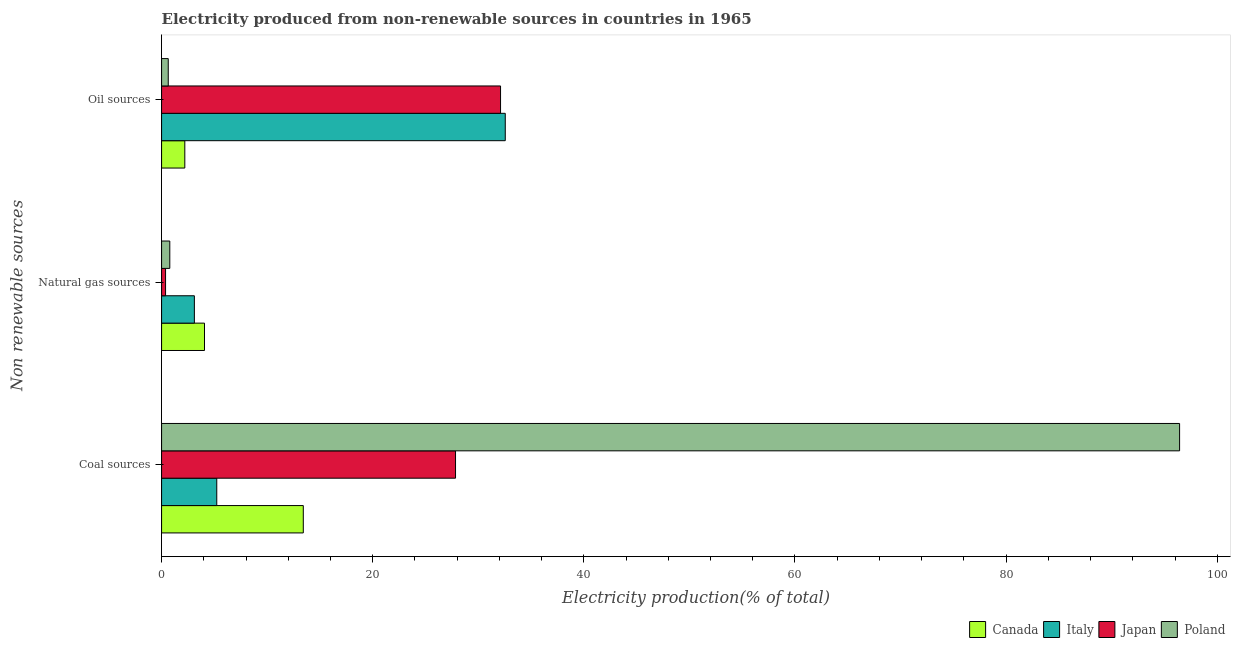How many different coloured bars are there?
Offer a very short reply. 4. How many groups of bars are there?
Keep it short and to the point. 3. Are the number of bars per tick equal to the number of legend labels?
Provide a succinct answer. Yes. What is the label of the 3rd group of bars from the top?
Give a very brief answer. Coal sources. What is the percentage of electricity produced by coal in Japan?
Your response must be concise. 27.85. Across all countries, what is the maximum percentage of electricity produced by coal?
Offer a very short reply. 96.43. Across all countries, what is the minimum percentage of electricity produced by oil sources?
Your answer should be very brief. 0.63. In which country was the percentage of electricity produced by natural gas minimum?
Make the answer very short. Japan. What is the total percentage of electricity produced by natural gas in the graph?
Keep it short and to the point. 8.33. What is the difference between the percentage of electricity produced by natural gas in Poland and that in Canada?
Offer a terse response. -3.29. What is the difference between the percentage of electricity produced by coal in Italy and the percentage of electricity produced by oil sources in Japan?
Provide a short and direct response. -26.88. What is the average percentage of electricity produced by oil sources per country?
Keep it short and to the point. 16.87. What is the difference between the percentage of electricity produced by natural gas and percentage of electricity produced by coal in Poland?
Make the answer very short. -95.65. What is the ratio of the percentage of electricity produced by coal in Italy to that in Poland?
Provide a succinct answer. 0.05. Is the percentage of electricity produced by natural gas in Poland less than that in Japan?
Keep it short and to the point. No. What is the difference between the highest and the second highest percentage of electricity produced by natural gas?
Offer a very short reply. 0.96. What is the difference between the highest and the lowest percentage of electricity produced by oil sources?
Ensure brevity in your answer.  31.92. Are all the bars in the graph horizontal?
Provide a short and direct response. Yes. What is the difference between two consecutive major ticks on the X-axis?
Your answer should be compact. 20. How many legend labels are there?
Offer a very short reply. 4. What is the title of the graph?
Provide a short and direct response. Electricity produced from non-renewable sources in countries in 1965. What is the label or title of the Y-axis?
Your answer should be very brief. Non renewable sources. What is the Electricity production(% of total) in Canada in Coal sources?
Give a very brief answer. 13.42. What is the Electricity production(% of total) of Italy in Coal sources?
Make the answer very short. 5.23. What is the Electricity production(% of total) of Japan in Coal sources?
Your answer should be compact. 27.85. What is the Electricity production(% of total) of Poland in Coal sources?
Provide a succinct answer. 96.43. What is the Electricity production(% of total) of Canada in Natural gas sources?
Your answer should be very brief. 4.07. What is the Electricity production(% of total) in Italy in Natural gas sources?
Offer a terse response. 3.11. What is the Electricity production(% of total) of Japan in Natural gas sources?
Offer a very short reply. 0.38. What is the Electricity production(% of total) of Poland in Natural gas sources?
Make the answer very short. 0.78. What is the Electricity production(% of total) in Canada in Oil sources?
Ensure brevity in your answer.  2.2. What is the Electricity production(% of total) of Italy in Oil sources?
Make the answer very short. 32.56. What is the Electricity production(% of total) of Japan in Oil sources?
Your response must be concise. 32.11. What is the Electricity production(% of total) of Poland in Oil sources?
Your response must be concise. 0.63. Across all Non renewable sources, what is the maximum Electricity production(% of total) of Canada?
Make the answer very short. 13.42. Across all Non renewable sources, what is the maximum Electricity production(% of total) in Italy?
Offer a very short reply. 32.56. Across all Non renewable sources, what is the maximum Electricity production(% of total) of Japan?
Your answer should be very brief. 32.11. Across all Non renewable sources, what is the maximum Electricity production(% of total) of Poland?
Ensure brevity in your answer.  96.43. Across all Non renewable sources, what is the minimum Electricity production(% of total) in Canada?
Offer a very short reply. 2.2. Across all Non renewable sources, what is the minimum Electricity production(% of total) of Italy?
Ensure brevity in your answer.  3.11. Across all Non renewable sources, what is the minimum Electricity production(% of total) in Japan?
Make the answer very short. 0.38. Across all Non renewable sources, what is the minimum Electricity production(% of total) of Poland?
Your answer should be very brief. 0.63. What is the total Electricity production(% of total) in Canada in the graph?
Offer a terse response. 19.69. What is the total Electricity production(% of total) in Italy in the graph?
Provide a succinct answer. 40.89. What is the total Electricity production(% of total) of Japan in the graph?
Provide a short and direct response. 60.33. What is the total Electricity production(% of total) in Poland in the graph?
Provide a short and direct response. 97.84. What is the difference between the Electricity production(% of total) of Canada in Coal sources and that in Natural gas sources?
Make the answer very short. 9.36. What is the difference between the Electricity production(% of total) in Italy in Coal sources and that in Natural gas sources?
Give a very brief answer. 2.12. What is the difference between the Electricity production(% of total) in Japan in Coal sources and that in Natural gas sources?
Offer a terse response. 27.47. What is the difference between the Electricity production(% of total) of Poland in Coal sources and that in Natural gas sources?
Your response must be concise. 95.65. What is the difference between the Electricity production(% of total) in Canada in Coal sources and that in Oil sources?
Offer a very short reply. 11.22. What is the difference between the Electricity production(% of total) of Italy in Coal sources and that in Oil sources?
Make the answer very short. -27.33. What is the difference between the Electricity production(% of total) of Japan in Coal sources and that in Oil sources?
Give a very brief answer. -4.26. What is the difference between the Electricity production(% of total) of Poland in Coal sources and that in Oil sources?
Keep it short and to the point. 95.8. What is the difference between the Electricity production(% of total) of Canada in Natural gas sources and that in Oil sources?
Offer a terse response. 1.86. What is the difference between the Electricity production(% of total) of Italy in Natural gas sources and that in Oil sources?
Ensure brevity in your answer.  -29.45. What is the difference between the Electricity production(% of total) of Japan in Natural gas sources and that in Oil sources?
Offer a terse response. -31.73. What is the difference between the Electricity production(% of total) of Poland in Natural gas sources and that in Oil sources?
Make the answer very short. 0.15. What is the difference between the Electricity production(% of total) of Canada in Coal sources and the Electricity production(% of total) of Italy in Natural gas sources?
Provide a succinct answer. 10.32. What is the difference between the Electricity production(% of total) of Canada in Coal sources and the Electricity production(% of total) of Japan in Natural gas sources?
Offer a very short reply. 13.05. What is the difference between the Electricity production(% of total) in Canada in Coal sources and the Electricity production(% of total) in Poland in Natural gas sources?
Your answer should be very brief. 12.65. What is the difference between the Electricity production(% of total) of Italy in Coal sources and the Electricity production(% of total) of Japan in Natural gas sources?
Provide a succinct answer. 4.85. What is the difference between the Electricity production(% of total) in Italy in Coal sources and the Electricity production(% of total) in Poland in Natural gas sources?
Your answer should be very brief. 4.45. What is the difference between the Electricity production(% of total) in Japan in Coal sources and the Electricity production(% of total) in Poland in Natural gas sources?
Make the answer very short. 27.07. What is the difference between the Electricity production(% of total) of Canada in Coal sources and the Electricity production(% of total) of Italy in Oil sources?
Your answer should be compact. -19.13. What is the difference between the Electricity production(% of total) of Canada in Coal sources and the Electricity production(% of total) of Japan in Oil sources?
Your response must be concise. -18.68. What is the difference between the Electricity production(% of total) in Canada in Coal sources and the Electricity production(% of total) in Poland in Oil sources?
Provide a short and direct response. 12.79. What is the difference between the Electricity production(% of total) of Italy in Coal sources and the Electricity production(% of total) of Japan in Oil sources?
Provide a succinct answer. -26.88. What is the difference between the Electricity production(% of total) in Italy in Coal sources and the Electricity production(% of total) in Poland in Oil sources?
Provide a succinct answer. 4.6. What is the difference between the Electricity production(% of total) of Japan in Coal sources and the Electricity production(% of total) of Poland in Oil sources?
Your answer should be compact. 27.21. What is the difference between the Electricity production(% of total) in Canada in Natural gas sources and the Electricity production(% of total) in Italy in Oil sources?
Ensure brevity in your answer.  -28.49. What is the difference between the Electricity production(% of total) in Canada in Natural gas sources and the Electricity production(% of total) in Japan in Oil sources?
Ensure brevity in your answer.  -28.04. What is the difference between the Electricity production(% of total) in Canada in Natural gas sources and the Electricity production(% of total) in Poland in Oil sources?
Offer a very short reply. 3.43. What is the difference between the Electricity production(% of total) in Italy in Natural gas sources and the Electricity production(% of total) in Japan in Oil sources?
Provide a succinct answer. -29. What is the difference between the Electricity production(% of total) of Italy in Natural gas sources and the Electricity production(% of total) of Poland in Oil sources?
Your response must be concise. 2.47. What is the difference between the Electricity production(% of total) of Japan in Natural gas sources and the Electricity production(% of total) of Poland in Oil sources?
Give a very brief answer. -0.26. What is the average Electricity production(% of total) in Canada per Non renewable sources?
Your response must be concise. 6.56. What is the average Electricity production(% of total) in Italy per Non renewable sources?
Ensure brevity in your answer.  13.63. What is the average Electricity production(% of total) in Japan per Non renewable sources?
Your response must be concise. 20.11. What is the average Electricity production(% of total) of Poland per Non renewable sources?
Offer a very short reply. 32.61. What is the difference between the Electricity production(% of total) in Canada and Electricity production(% of total) in Italy in Coal sources?
Make the answer very short. 8.2. What is the difference between the Electricity production(% of total) in Canada and Electricity production(% of total) in Japan in Coal sources?
Provide a succinct answer. -14.42. What is the difference between the Electricity production(% of total) in Canada and Electricity production(% of total) in Poland in Coal sources?
Ensure brevity in your answer.  -83.01. What is the difference between the Electricity production(% of total) in Italy and Electricity production(% of total) in Japan in Coal sources?
Ensure brevity in your answer.  -22.62. What is the difference between the Electricity production(% of total) in Italy and Electricity production(% of total) in Poland in Coal sources?
Make the answer very short. -91.2. What is the difference between the Electricity production(% of total) of Japan and Electricity production(% of total) of Poland in Coal sources?
Your response must be concise. -68.59. What is the difference between the Electricity production(% of total) in Canada and Electricity production(% of total) in Italy in Natural gas sources?
Offer a very short reply. 0.96. What is the difference between the Electricity production(% of total) of Canada and Electricity production(% of total) of Japan in Natural gas sources?
Provide a succinct answer. 3.69. What is the difference between the Electricity production(% of total) of Canada and Electricity production(% of total) of Poland in Natural gas sources?
Keep it short and to the point. 3.29. What is the difference between the Electricity production(% of total) of Italy and Electricity production(% of total) of Japan in Natural gas sources?
Ensure brevity in your answer.  2.73. What is the difference between the Electricity production(% of total) of Italy and Electricity production(% of total) of Poland in Natural gas sources?
Ensure brevity in your answer.  2.33. What is the difference between the Electricity production(% of total) of Japan and Electricity production(% of total) of Poland in Natural gas sources?
Ensure brevity in your answer.  -0.4. What is the difference between the Electricity production(% of total) of Canada and Electricity production(% of total) of Italy in Oil sources?
Keep it short and to the point. -30.36. What is the difference between the Electricity production(% of total) in Canada and Electricity production(% of total) in Japan in Oil sources?
Make the answer very short. -29.91. What is the difference between the Electricity production(% of total) in Canada and Electricity production(% of total) in Poland in Oil sources?
Your answer should be compact. 1.57. What is the difference between the Electricity production(% of total) in Italy and Electricity production(% of total) in Japan in Oil sources?
Your answer should be very brief. 0.45. What is the difference between the Electricity production(% of total) of Italy and Electricity production(% of total) of Poland in Oil sources?
Make the answer very short. 31.92. What is the difference between the Electricity production(% of total) in Japan and Electricity production(% of total) in Poland in Oil sources?
Give a very brief answer. 31.48. What is the ratio of the Electricity production(% of total) in Canada in Coal sources to that in Natural gas sources?
Provide a short and direct response. 3.3. What is the ratio of the Electricity production(% of total) in Italy in Coal sources to that in Natural gas sources?
Provide a succinct answer. 1.68. What is the ratio of the Electricity production(% of total) in Japan in Coal sources to that in Natural gas sources?
Offer a terse response. 73.76. What is the ratio of the Electricity production(% of total) in Poland in Coal sources to that in Natural gas sources?
Keep it short and to the point. 123.82. What is the ratio of the Electricity production(% of total) of Canada in Coal sources to that in Oil sources?
Your answer should be compact. 6.1. What is the ratio of the Electricity production(% of total) in Italy in Coal sources to that in Oil sources?
Ensure brevity in your answer.  0.16. What is the ratio of the Electricity production(% of total) in Japan in Coal sources to that in Oil sources?
Offer a very short reply. 0.87. What is the ratio of the Electricity production(% of total) of Poland in Coal sources to that in Oil sources?
Your response must be concise. 152.43. What is the ratio of the Electricity production(% of total) in Canada in Natural gas sources to that in Oil sources?
Keep it short and to the point. 1.85. What is the ratio of the Electricity production(% of total) in Italy in Natural gas sources to that in Oil sources?
Provide a short and direct response. 0.1. What is the ratio of the Electricity production(% of total) of Japan in Natural gas sources to that in Oil sources?
Keep it short and to the point. 0.01. What is the ratio of the Electricity production(% of total) in Poland in Natural gas sources to that in Oil sources?
Keep it short and to the point. 1.23. What is the difference between the highest and the second highest Electricity production(% of total) of Canada?
Keep it short and to the point. 9.36. What is the difference between the highest and the second highest Electricity production(% of total) in Italy?
Ensure brevity in your answer.  27.33. What is the difference between the highest and the second highest Electricity production(% of total) in Japan?
Provide a succinct answer. 4.26. What is the difference between the highest and the second highest Electricity production(% of total) of Poland?
Make the answer very short. 95.65. What is the difference between the highest and the lowest Electricity production(% of total) of Canada?
Make the answer very short. 11.22. What is the difference between the highest and the lowest Electricity production(% of total) in Italy?
Ensure brevity in your answer.  29.45. What is the difference between the highest and the lowest Electricity production(% of total) in Japan?
Your answer should be compact. 31.73. What is the difference between the highest and the lowest Electricity production(% of total) in Poland?
Keep it short and to the point. 95.8. 